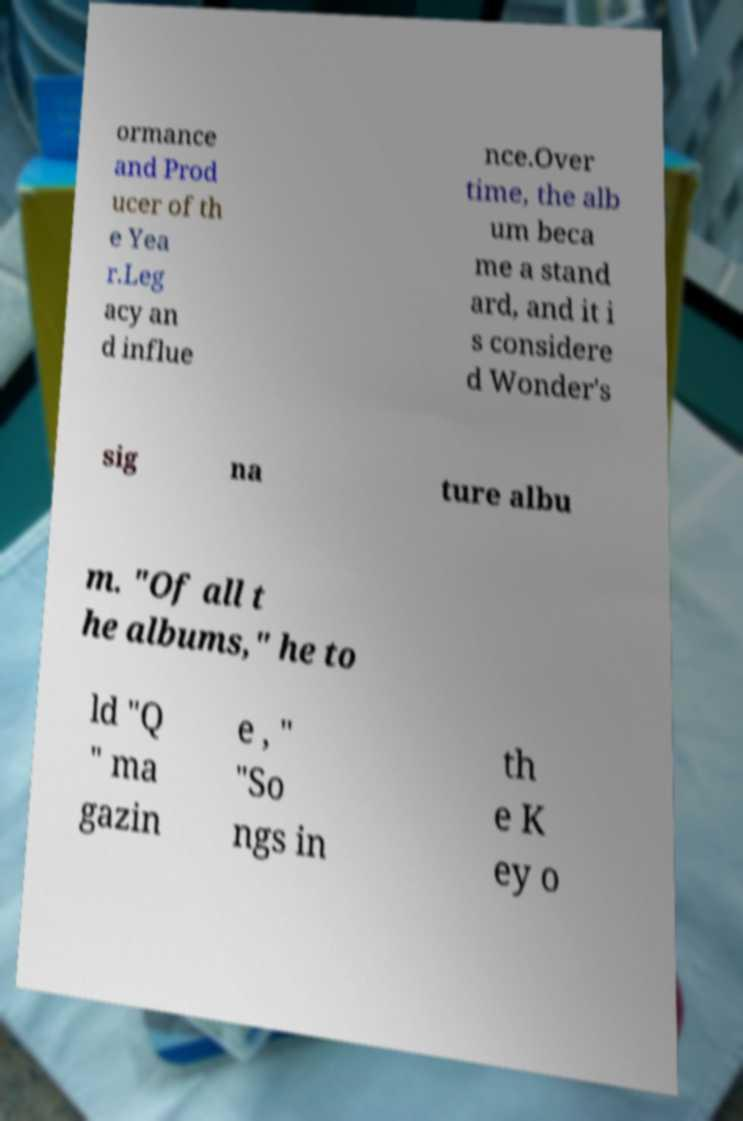Can you read and provide the text displayed in the image?This photo seems to have some interesting text. Can you extract and type it out for me? ormance and Prod ucer of th e Yea r.Leg acy an d influe nce.Over time, the alb um beca me a stand ard, and it i s considere d Wonder's sig na ture albu m. "Of all t he albums," he to ld "Q " ma gazin e , " "So ngs in th e K ey o 